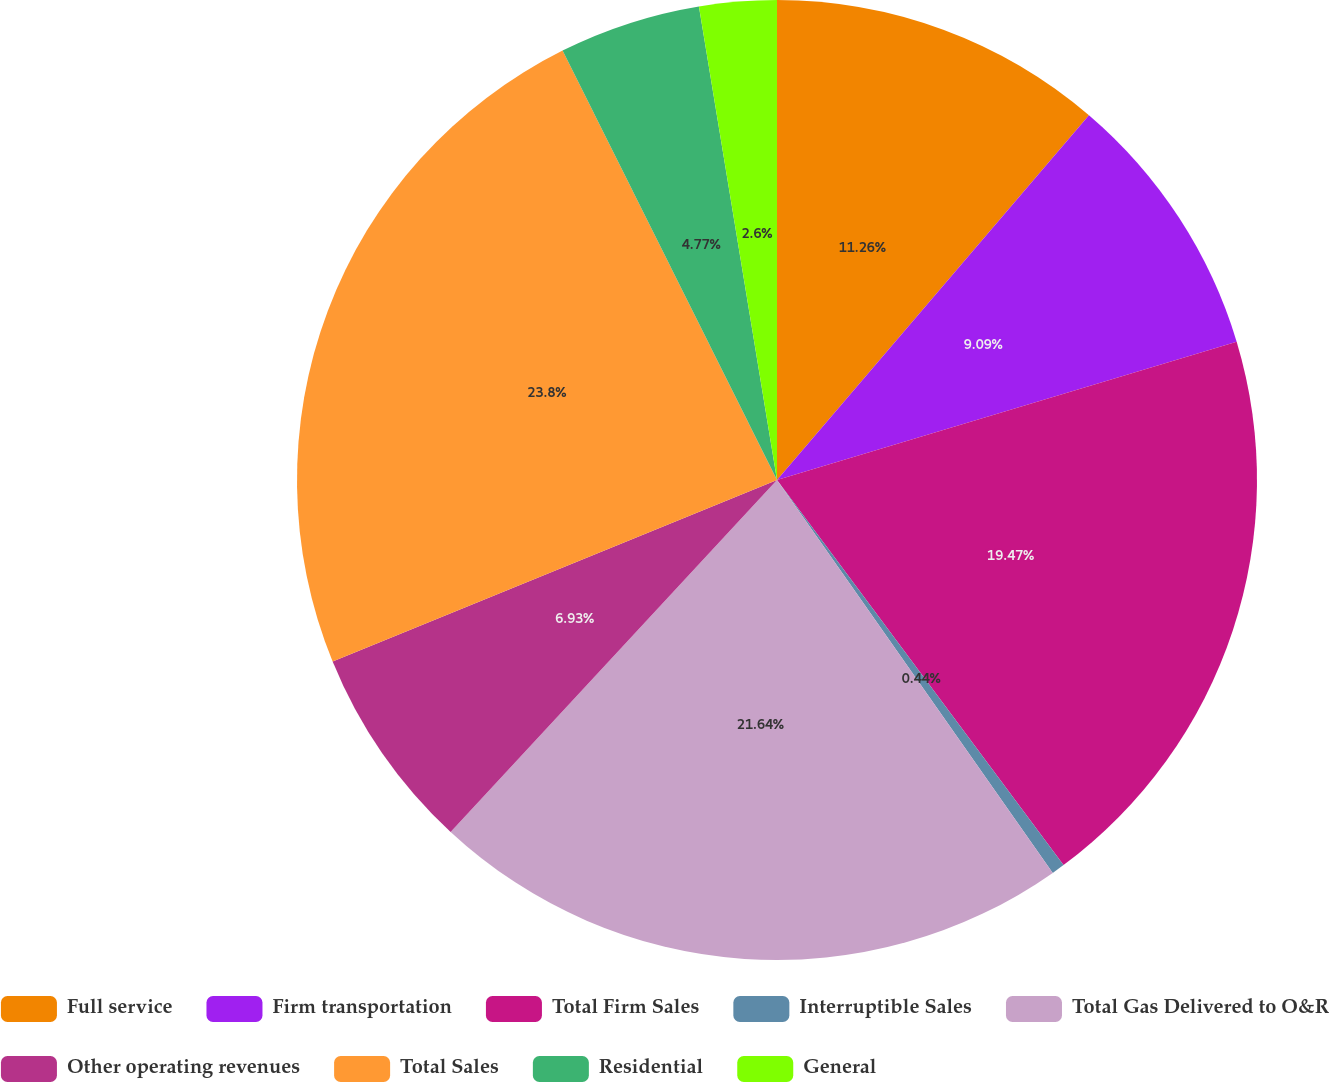Convert chart. <chart><loc_0><loc_0><loc_500><loc_500><pie_chart><fcel>Full service<fcel>Firm transportation<fcel>Total Firm Sales<fcel>Interruptible Sales<fcel>Total Gas Delivered to O&R<fcel>Other operating revenues<fcel>Total Sales<fcel>Residential<fcel>General<nl><fcel>11.26%<fcel>9.09%<fcel>19.47%<fcel>0.44%<fcel>21.64%<fcel>6.93%<fcel>23.8%<fcel>4.77%<fcel>2.6%<nl></chart> 